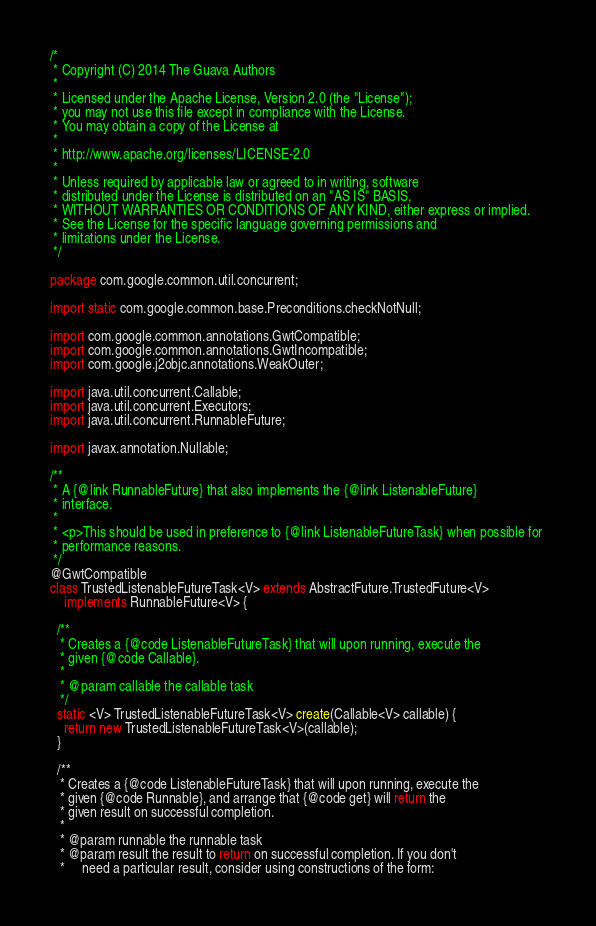<code> <loc_0><loc_0><loc_500><loc_500><_Java_>/*
 * Copyright (C) 2014 The Guava Authors
 *
 * Licensed under the Apache License, Version 2.0 (the "License");
 * you may not use this file except in compliance with the License.
 * You may obtain a copy of the License at
 *
 * http://www.apache.org/licenses/LICENSE-2.0
 *
 * Unless required by applicable law or agreed to in writing, software
 * distributed under the License is distributed on an "AS IS" BASIS,
 * WITHOUT WARRANTIES OR CONDITIONS OF ANY KIND, either express or implied.
 * See the License for the specific language governing permissions and
 * limitations under the License.
 */

package com.google.common.util.concurrent;

import static com.google.common.base.Preconditions.checkNotNull;

import com.google.common.annotations.GwtCompatible;
import com.google.common.annotations.GwtIncompatible;
import com.google.j2objc.annotations.WeakOuter;

import java.util.concurrent.Callable;
import java.util.concurrent.Executors;
import java.util.concurrent.RunnableFuture;

import javax.annotation.Nullable;

/**
 * A {@link RunnableFuture} that also implements the {@link ListenableFuture}
 * interface.
 * 
 * <p>This should be used in preference to {@link ListenableFutureTask} when possible for 
 * performance reasons.
 */
@GwtCompatible
class TrustedListenableFutureTask<V> extends AbstractFuture.TrustedFuture<V>
    implements RunnableFuture<V> {

  /**
   * Creates a {@code ListenableFutureTask} that will upon running, execute the
   * given {@code Callable}.
   *
   * @param callable the callable task
   */
  static <V> TrustedListenableFutureTask<V> create(Callable<V> callable) {
    return new TrustedListenableFutureTask<V>(callable);
  }

  /**
   * Creates a {@code ListenableFutureTask} that will upon running, execute the
   * given {@code Runnable}, and arrange that {@code get} will return the
   * given result on successful completion.
   *
   * @param runnable the runnable task
   * @param result the result to return on successful completion. If you don't
   *     need a particular result, consider using constructions of the form:</code> 